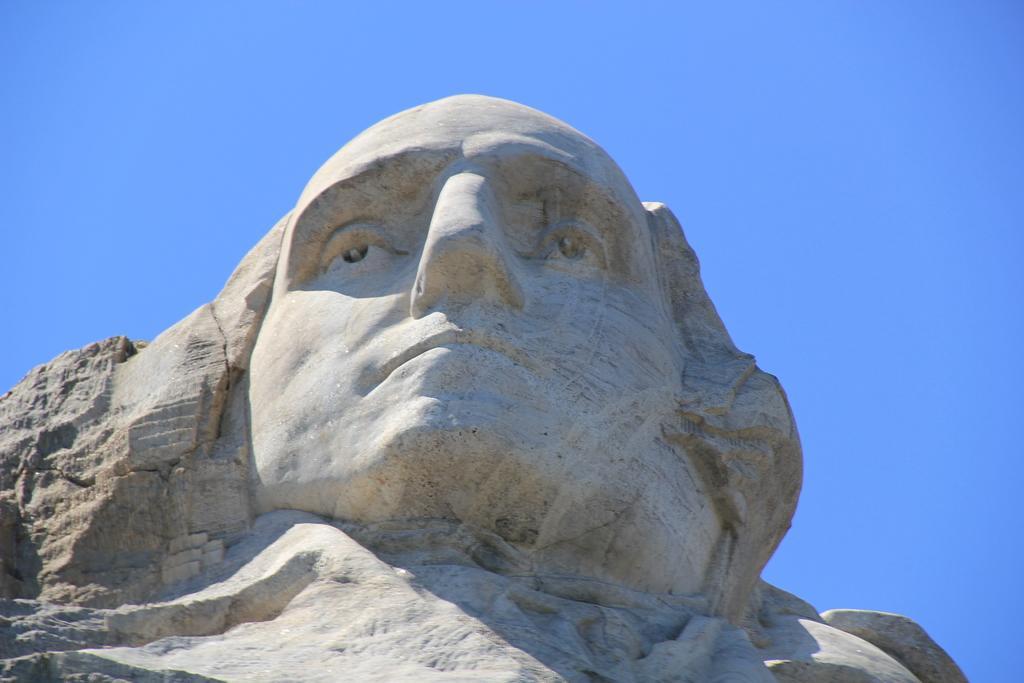Describe this image in one or two sentences. This picture contains a stone carved statue. In the background, we see the sky, which is blue in color. 